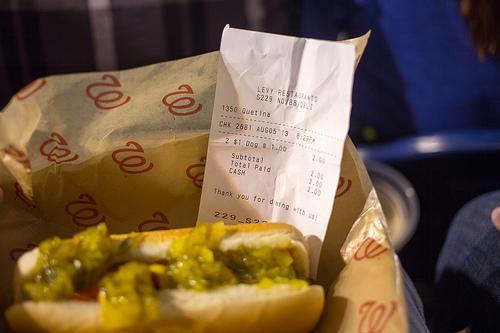How many receipts are there?
Give a very brief answer. 1. 